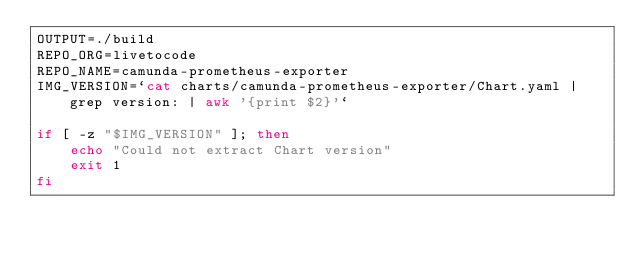<code> <loc_0><loc_0><loc_500><loc_500><_Bash_>OUTPUT=./build
REPO_ORG=livetocode
REPO_NAME=camunda-prometheus-exporter
IMG_VERSION=`cat charts/camunda-prometheus-exporter/Chart.yaml |grep version: | awk '{print $2}'`

if [ -z "$IMG_VERSION" ]; then
    echo "Could not extract Chart version"
    exit 1
fi
</code> 